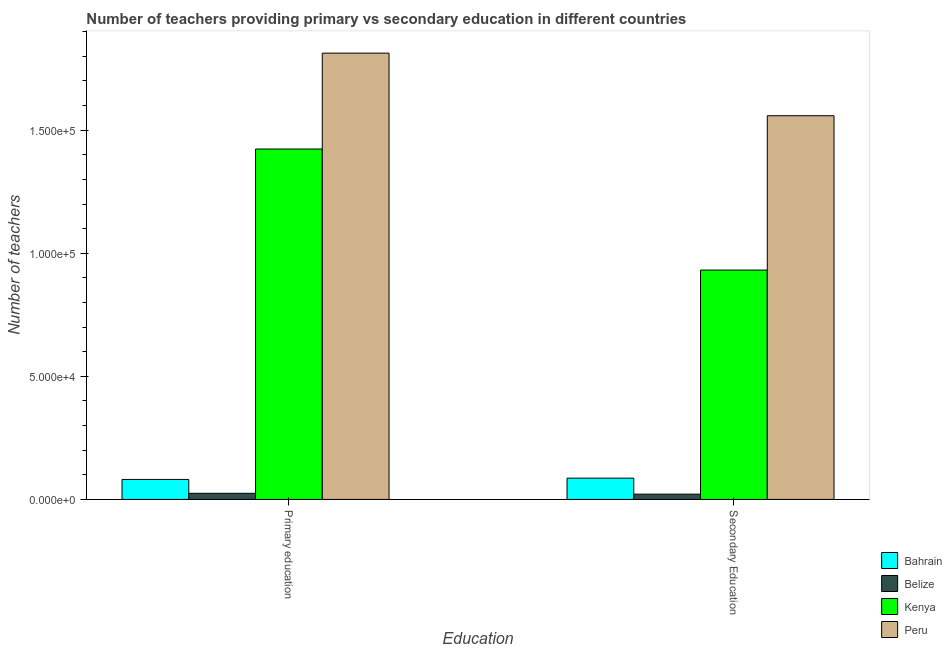How many groups of bars are there?
Make the answer very short. 2. Are the number of bars per tick equal to the number of legend labels?
Offer a very short reply. Yes. How many bars are there on the 2nd tick from the right?
Ensure brevity in your answer.  4. What is the label of the 2nd group of bars from the left?
Your response must be concise. Secondary Education. What is the number of secondary teachers in Kenya?
Offer a terse response. 9.32e+04. Across all countries, what is the maximum number of primary teachers?
Ensure brevity in your answer.  1.81e+05. Across all countries, what is the minimum number of primary teachers?
Provide a short and direct response. 2486. In which country was the number of primary teachers maximum?
Your answer should be very brief. Peru. In which country was the number of secondary teachers minimum?
Ensure brevity in your answer.  Belize. What is the total number of secondary teachers in the graph?
Your response must be concise. 2.60e+05. What is the difference between the number of secondary teachers in Peru and that in Kenya?
Ensure brevity in your answer.  6.27e+04. What is the difference between the number of secondary teachers in Peru and the number of primary teachers in Kenya?
Ensure brevity in your answer.  1.35e+04. What is the average number of secondary teachers per country?
Offer a terse response. 6.50e+04. What is the difference between the number of primary teachers and number of secondary teachers in Bahrain?
Your response must be concise. -529. What is the ratio of the number of primary teachers in Bahrain to that in Kenya?
Ensure brevity in your answer.  0.06. In how many countries, is the number of primary teachers greater than the average number of primary teachers taken over all countries?
Your answer should be very brief. 2. What does the 1st bar from the left in Primary education represents?
Give a very brief answer. Bahrain. What does the 4th bar from the right in Secondary Education represents?
Your response must be concise. Bahrain. How many bars are there?
Give a very brief answer. 8. Are all the bars in the graph horizontal?
Offer a very short reply. No. Does the graph contain any zero values?
Ensure brevity in your answer.  No. Does the graph contain grids?
Your answer should be very brief. No. Where does the legend appear in the graph?
Offer a very short reply. Bottom right. What is the title of the graph?
Offer a terse response. Number of teachers providing primary vs secondary education in different countries. Does "Lithuania" appear as one of the legend labels in the graph?
Ensure brevity in your answer.  No. What is the label or title of the X-axis?
Give a very brief answer. Education. What is the label or title of the Y-axis?
Provide a succinct answer. Number of teachers. What is the Number of teachers of Bahrain in Primary education?
Provide a short and direct response. 8117. What is the Number of teachers in Belize in Primary education?
Provide a succinct answer. 2486. What is the Number of teachers in Kenya in Primary education?
Offer a terse response. 1.42e+05. What is the Number of teachers in Peru in Primary education?
Make the answer very short. 1.81e+05. What is the Number of teachers of Bahrain in Secondary Education?
Provide a succinct answer. 8646. What is the Number of teachers of Belize in Secondary Education?
Your answer should be compact. 2142. What is the Number of teachers of Kenya in Secondary Education?
Offer a terse response. 9.32e+04. What is the Number of teachers in Peru in Secondary Education?
Ensure brevity in your answer.  1.56e+05. Across all Education, what is the maximum Number of teachers of Bahrain?
Ensure brevity in your answer.  8646. Across all Education, what is the maximum Number of teachers in Belize?
Offer a very short reply. 2486. Across all Education, what is the maximum Number of teachers of Kenya?
Give a very brief answer. 1.42e+05. Across all Education, what is the maximum Number of teachers in Peru?
Provide a succinct answer. 1.81e+05. Across all Education, what is the minimum Number of teachers of Bahrain?
Offer a very short reply. 8117. Across all Education, what is the minimum Number of teachers of Belize?
Offer a terse response. 2142. Across all Education, what is the minimum Number of teachers of Kenya?
Your response must be concise. 9.32e+04. Across all Education, what is the minimum Number of teachers in Peru?
Offer a terse response. 1.56e+05. What is the total Number of teachers of Bahrain in the graph?
Provide a succinct answer. 1.68e+04. What is the total Number of teachers of Belize in the graph?
Offer a very short reply. 4628. What is the total Number of teachers in Kenya in the graph?
Offer a very short reply. 2.36e+05. What is the total Number of teachers of Peru in the graph?
Provide a succinct answer. 3.37e+05. What is the difference between the Number of teachers in Bahrain in Primary education and that in Secondary Education?
Provide a succinct answer. -529. What is the difference between the Number of teachers of Belize in Primary education and that in Secondary Education?
Keep it short and to the point. 344. What is the difference between the Number of teachers of Kenya in Primary education and that in Secondary Education?
Provide a short and direct response. 4.92e+04. What is the difference between the Number of teachers in Peru in Primary education and that in Secondary Education?
Make the answer very short. 2.54e+04. What is the difference between the Number of teachers in Bahrain in Primary education and the Number of teachers in Belize in Secondary Education?
Give a very brief answer. 5975. What is the difference between the Number of teachers in Bahrain in Primary education and the Number of teachers in Kenya in Secondary Education?
Offer a very short reply. -8.51e+04. What is the difference between the Number of teachers of Bahrain in Primary education and the Number of teachers of Peru in Secondary Education?
Offer a terse response. -1.48e+05. What is the difference between the Number of teachers in Belize in Primary education and the Number of teachers in Kenya in Secondary Education?
Make the answer very short. -9.07e+04. What is the difference between the Number of teachers in Belize in Primary education and the Number of teachers in Peru in Secondary Education?
Keep it short and to the point. -1.53e+05. What is the difference between the Number of teachers in Kenya in Primary education and the Number of teachers in Peru in Secondary Education?
Give a very brief answer. -1.35e+04. What is the average Number of teachers in Bahrain per Education?
Provide a succinct answer. 8381.5. What is the average Number of teachers in Belize per Education?
Provide a short and direct response. 2314. What is the average Number of teachers of Kenya per Education?
Ensure brevity in your answer.  1.18e+05. What is the average Number of teachers in Peru per Education?
Offer a very short reply. 1.69e+05. What is the difference between the Number of teachers in Bahrain and Number of teachers in Belize in Primary education?
Offer a terse response. 5631. What is the difference between the Number of teachers in Bahrain and Number of teachers in Kenya in Primary education?
Offer a terse response. -1.34e+05. What is the difference between the Number of teachers in Bahrain and Number of teachers in Peru in Primary education?
Provide a succinct answer. -1.73e+05. What is the difference between the Number of teachers in Belize and Number of teachers in Kenya in Primary education?
Offer a very short reply. -1.40e+05. What is the difference between the Number of teachers in Belize and Number of teachers in Peru in Primary education?
Offer a very short reply. -1.79e+05. What is the difference between the Number of teachers in Kenya and Number of teachers in Peru in Primary education?
Give a very brief answer. -3.89e+04. What is the difference between the Number of teachers in Bahrain and Number of teachers in Belize in Secondary Education?
Offer a terse response. 6504. What is the difference between the Number of teachers of Bahrain and Number of teachers of Kenya in Secondary Education?
Provide a short and direct response. -8.45e+04. What is the difference between the Number of teachers in Bahrain and Number of teachers in Peru in Secondary Education?
Your response must be concise. -1.47e+05. What is the difference between the Number of teachers of Belize and Number of teachers of Kenya in Secondary Education?
Your response must be concise. -9.10e+04. What is the difference between the Number of teachers of Belize and Number of teachers of Peru in Secondary Education?
Your answer should be compact. -1.54e+05. What is the difference between the Number of teachers of Kenya and Number of teachers of Peru in Secondary Education?
Offer a very short reply. -6.27e+04. What is the ratio of the Number of teachers in Bahrain in Primary education to that in Secondary Education?
Your response must be concise. 0.94. What is the ratio of the Number of teachers in Belize in Primary education to that in Secondary Education?
Your response must be concise. 1.16. What is the ratio of the Number of teachers in Kenya in Primary education to that in Secondary Education?
Ensure brevity in your answer.  1.53. What is the ratio of the Number of teachers in Peru in Primary education to that in Secondary Education?
Offer a very short reply. 1.16. What is the difference between the highest and the second highest Number of teachers of Bahrain?
Your response must be concise. 529. What is the difference between the highest and the second highest Number of teachers in Belize?
Make the answer very short. 344. What is the difference between the highest and the second highest Number of teachers in Kenya?
Your answer should be compact. 4.92e+04. What is the difference between the highest and the second highest Number of teachers of Peru?
Offer a terse response. 2.54e+04. What is the difference between the highest and the lowest Number of teachers in Bahrain?
Your answer should be very brief. 529. What is the difference between the highest and the lowest Number of teachers in Belize?
Offer a terse response. 344. What is the difference between the highest and the lowest Number of teachers in Kenya?
Provide a short and direct response. 4.92e+04. What is the difference between the highest and the lowest Number of teachers in Peru?
Provide a succinct answer. 2.54e+04. 